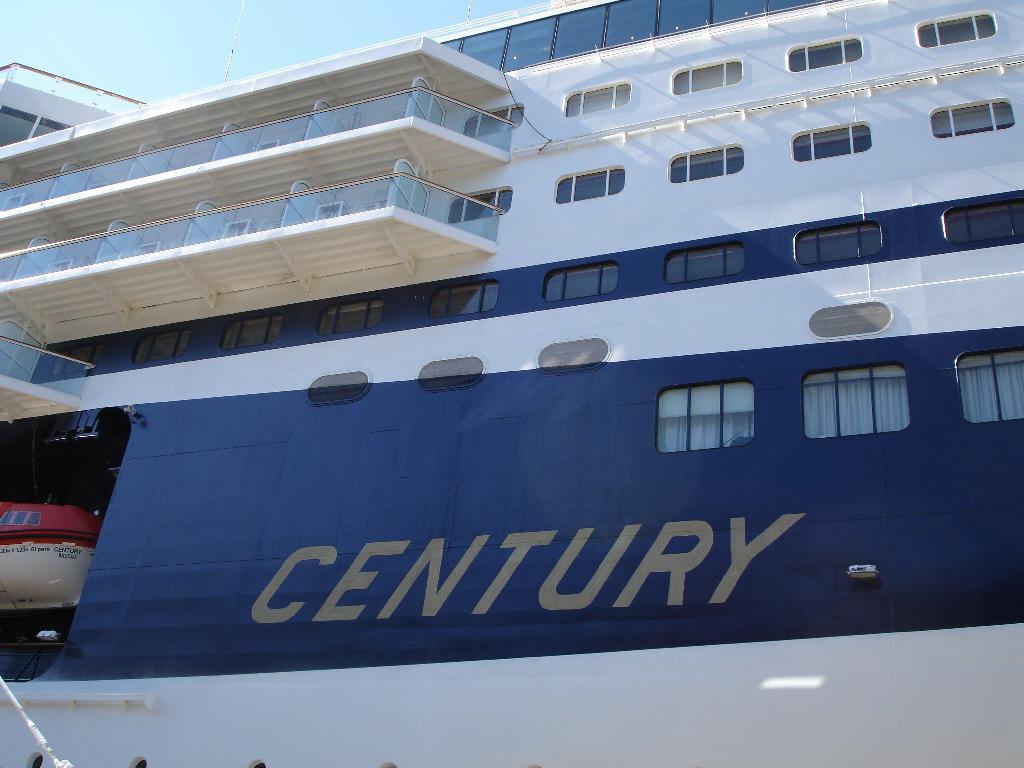How would you summarize this image in a sentence or two? In this image, we can see a ship, we can see some windows and corridors of the ship, at the top there is a sky. 